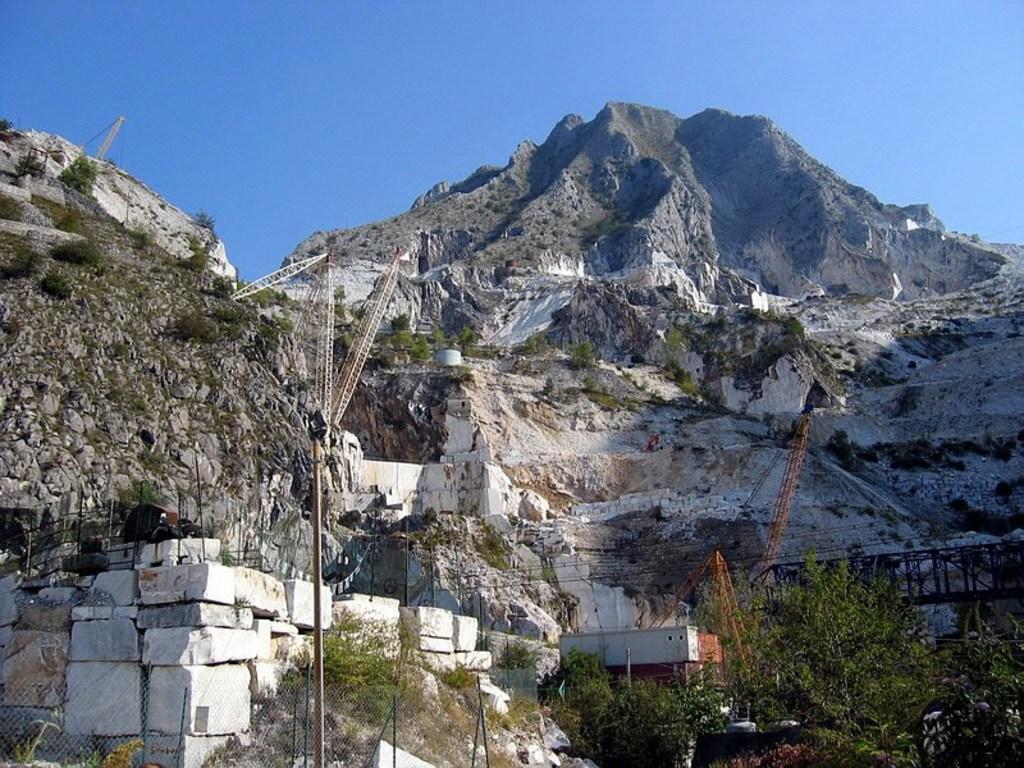Please provide a concise description of this image. In this picture we can see trees, fence, rocks, poles, mountains, some objects and in the background we can see the sky. 